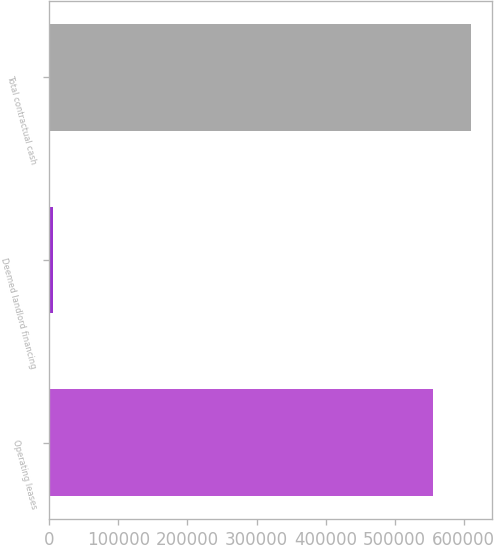<chart> <loc_0><loc_0><loc_500><loc_500><bar_chart><fcel>Operating leases<fcel>Deemed landlord financing<fcel>Total contractual cash<nl><fcel>555464<fcel>5273<fcel>611010<nl></chart> 